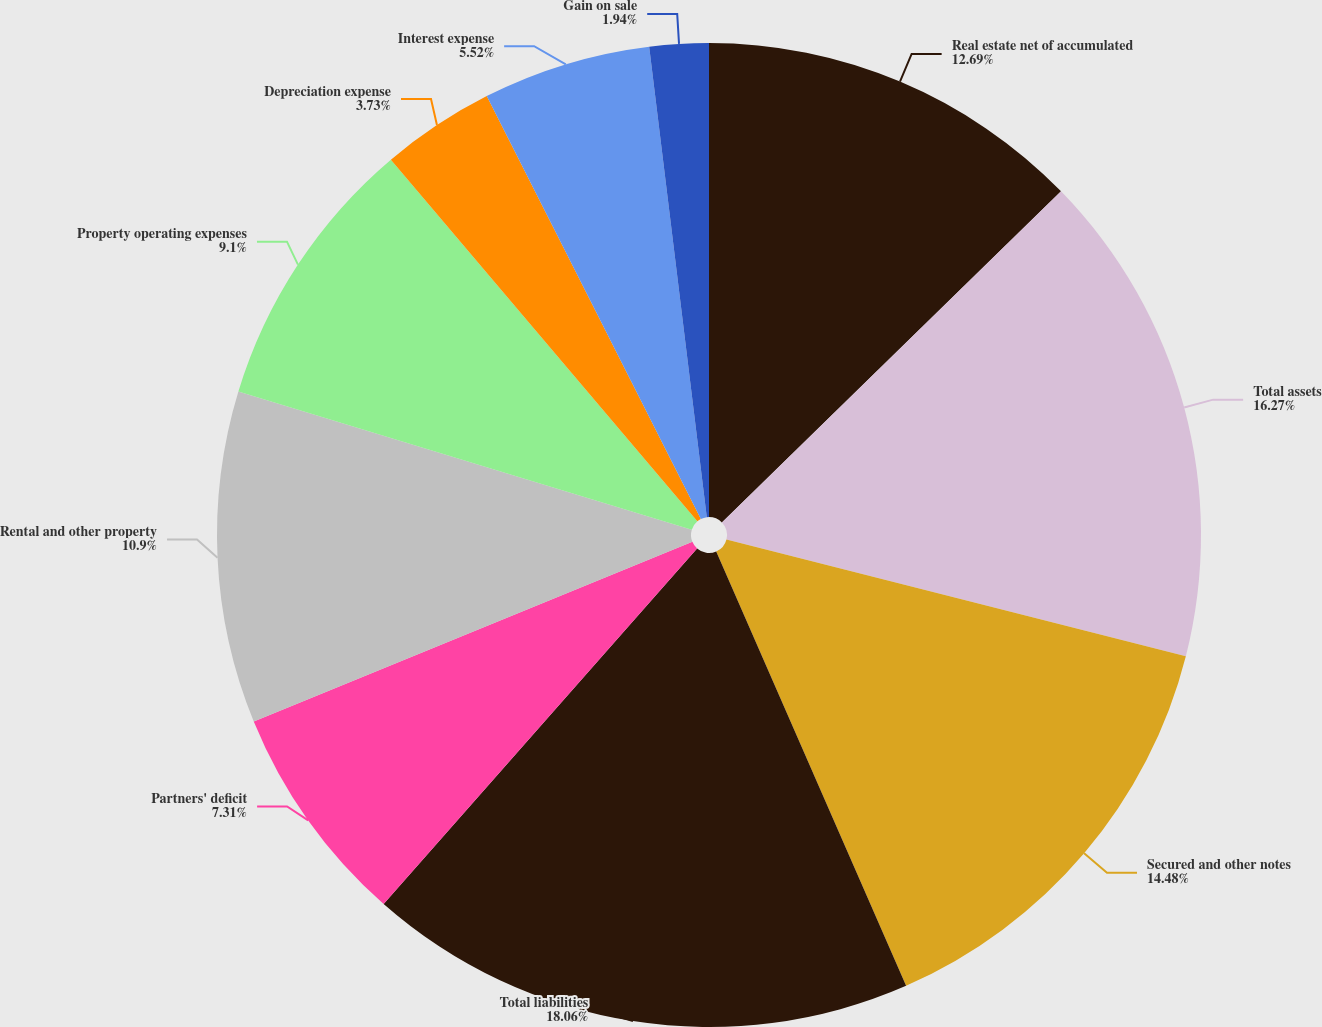Convert chart to OTSL. <chart><loc_0><loc_0><loc_500><loc_500><pie_chart><fcel>Real estate net of accumulated<fcel>Total assets<fcel>Secured and other notes<fcel>Total liabilities<fcel>Partners' deficit<fcel>Rental and other property<fcel>Property operating expenses<fcel>Depreciation expense<fcel>Interest expense<fcel>Gain on sale<nl><fcel>12.69%<fcel>16.27%<fcel>14.48%<fcel>18.06%<fcel>7.31%<fcel>10.9%<fcel>9.1%<fcel>3.73%<fcel>5.52%<fcel>1.94%<nl></chart> 